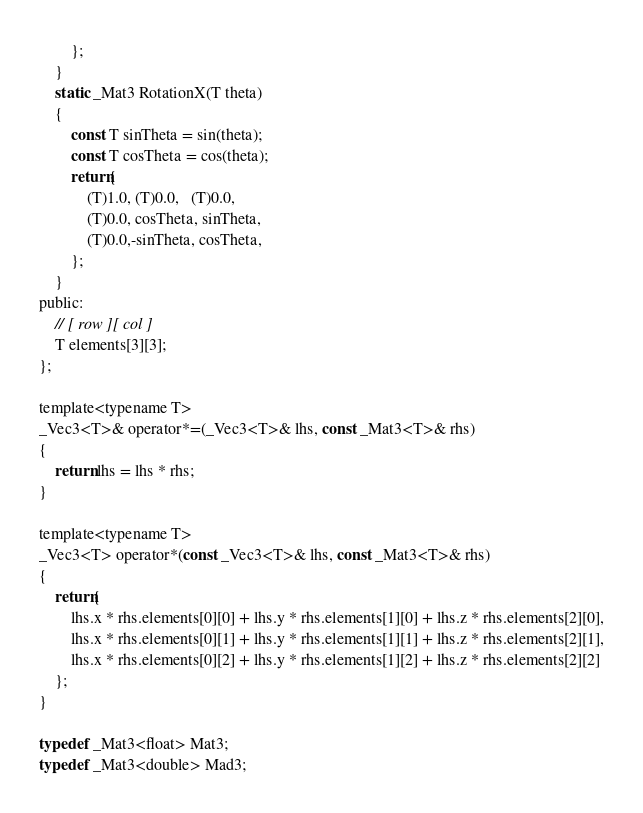Convert code to text. <code><loc_0><loc_0><loc_500><loc_500><_C_>		};
	}
	static _Mat3 RotationX(T theta)
	{
		const T sinTheta = sin(theta);
		const T cosTheta = cos(theta);
		return{
			(T)1.0, (T)0.0,   (T)0.0,
			(T)0.0, cosTheta, sinTheta,
			(T)0.0,-sinTheta, cosTheta,
		};
	}
public:
	// [ row ][ col ]
	T elements[3][3];
};

template<typename T>
_Vec3<T>& operator*=(_Vec3<T>& lhs, const _Mat3<T>& rhs)
{
	return lhs = lhs * rhs;
}

template<typename T>
_Vec3<T> operator*(const _Vec3<T>& lhs, const _Mat3<T>& rhs)
{
	return{
		lhs.x * rhs.elements[0][0] + lhs.y * rhs.elements[1][0] + lhs.z * rhs.elements[2][0],
		lhs.x * rhs.elements[0][1] + lhs.y * rhs.elements[1][1] + lhs.z * rhs.elements[2][1],
		lhs.x * rhs.elements[0][2] + lhs.y * rhs.elements[1][2] + lhs.z * rhs.elements[2][2]
	};
}

typedef _Mat3<float> Mat3;
typedef _Mat3<double> Mad3;</code> 